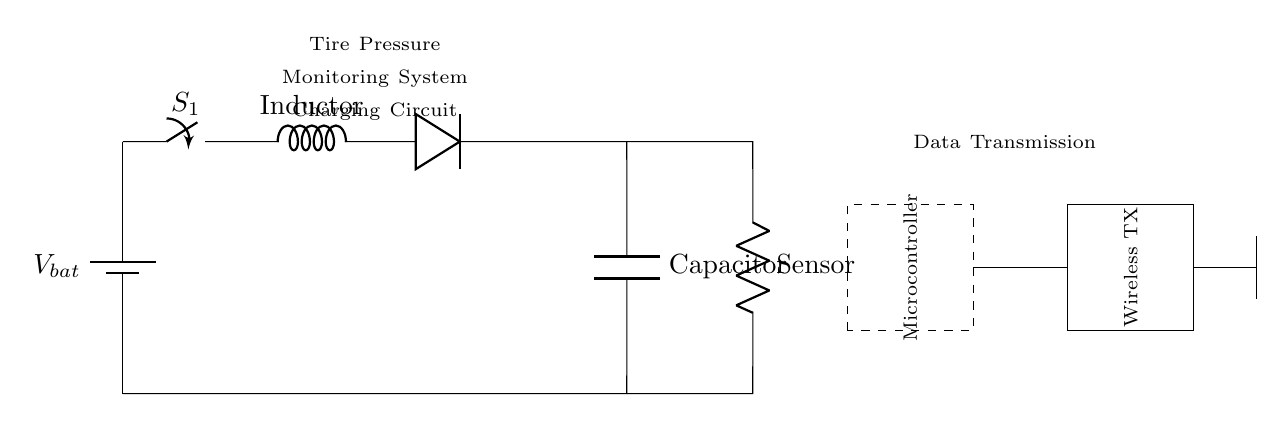What is the voltage source in the circuit? The circuit includes a battery labeled as V bat, which acts as the voltage source providing the necessary electrical potential for the charging circuit.
Answer: V bat What component is used for energy storage? The circuit features a capacitor labeled as Capacitor, which stores electrical energy for later use in the tire pressure monitoring system.
Answer: Capacitor What role does the inductor play in this circuit? The inductor, labeled as Inductor, is used to store energy in the magnetic field when current flows through it, helping to control the voltage and current in the charging circuit.
Answer: Inductor Which component is responsible for preventing reverse current flow? The diode is responsible for allowing current to flow in one direction only, preventing reverse current flow, which could damage the charging circuit.
Answer: Diode What is the function of the microcontroller in this circuit? The microcontroller manages the data from the tire pressure sensor and controls the wireless transmitter, coordinating the overall system operation.
Answer: Microcontroller How many main sections are present in this charging circuit? The charging circuit consists of three main sections: the power source, the charging components (inductor, diode, capacitor), and the data transmission section utilizing the microcontroller and wireless transmitter.
Answer: Three What type of transmission method is used for data? The circuit utilizes a wireless transmitter, which communicates the sensor data wirelessly, allowing for real-time monitoring without physical connections.
Answer: Wireless 